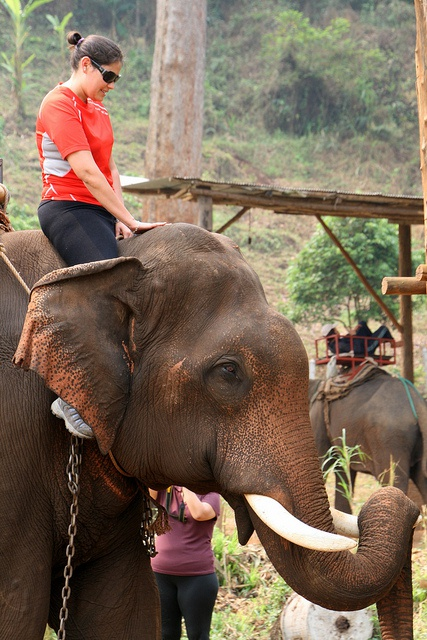Describe the objects in this image and their specific colors. I can see elephant in lightgreen, black, maroon, and gray tones, people in lightgreen, black, salmon, and red tones, elephant in lightgreen, gray, maroon, and black tones, and people in lightgreen, black, maroon, and brown tones in this image. 